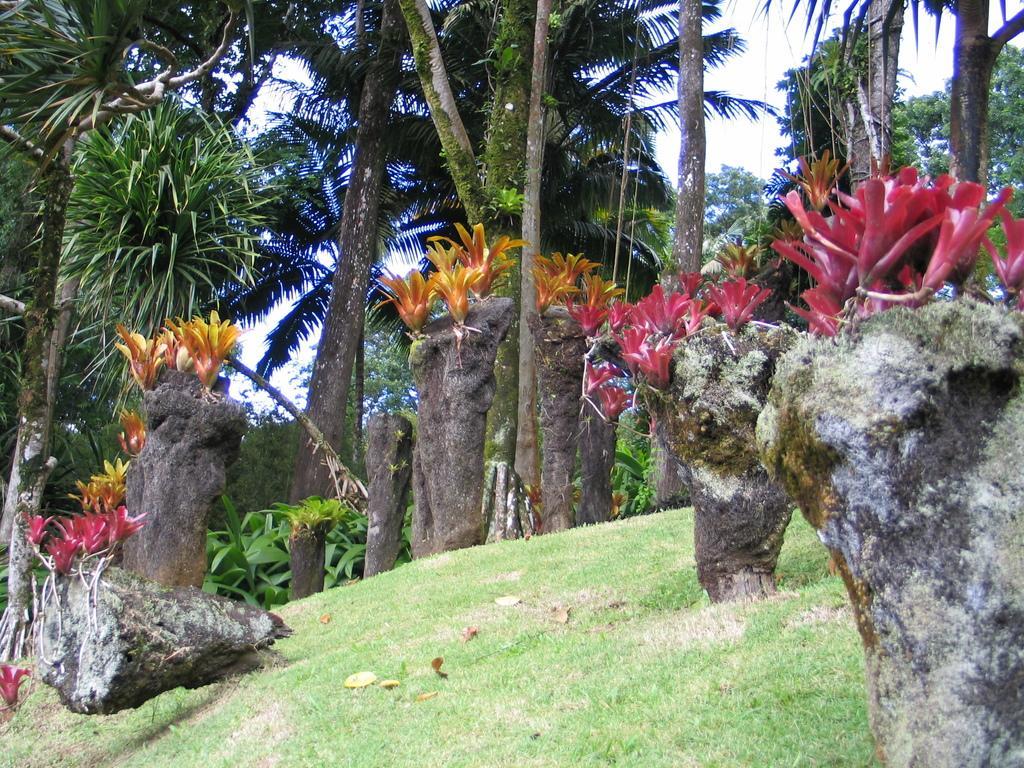Can you describe this image briefly? In this image we can see group of flowers on plants. In the foreground we can see the grass. In the background, we can see a group of trees and the sky. 